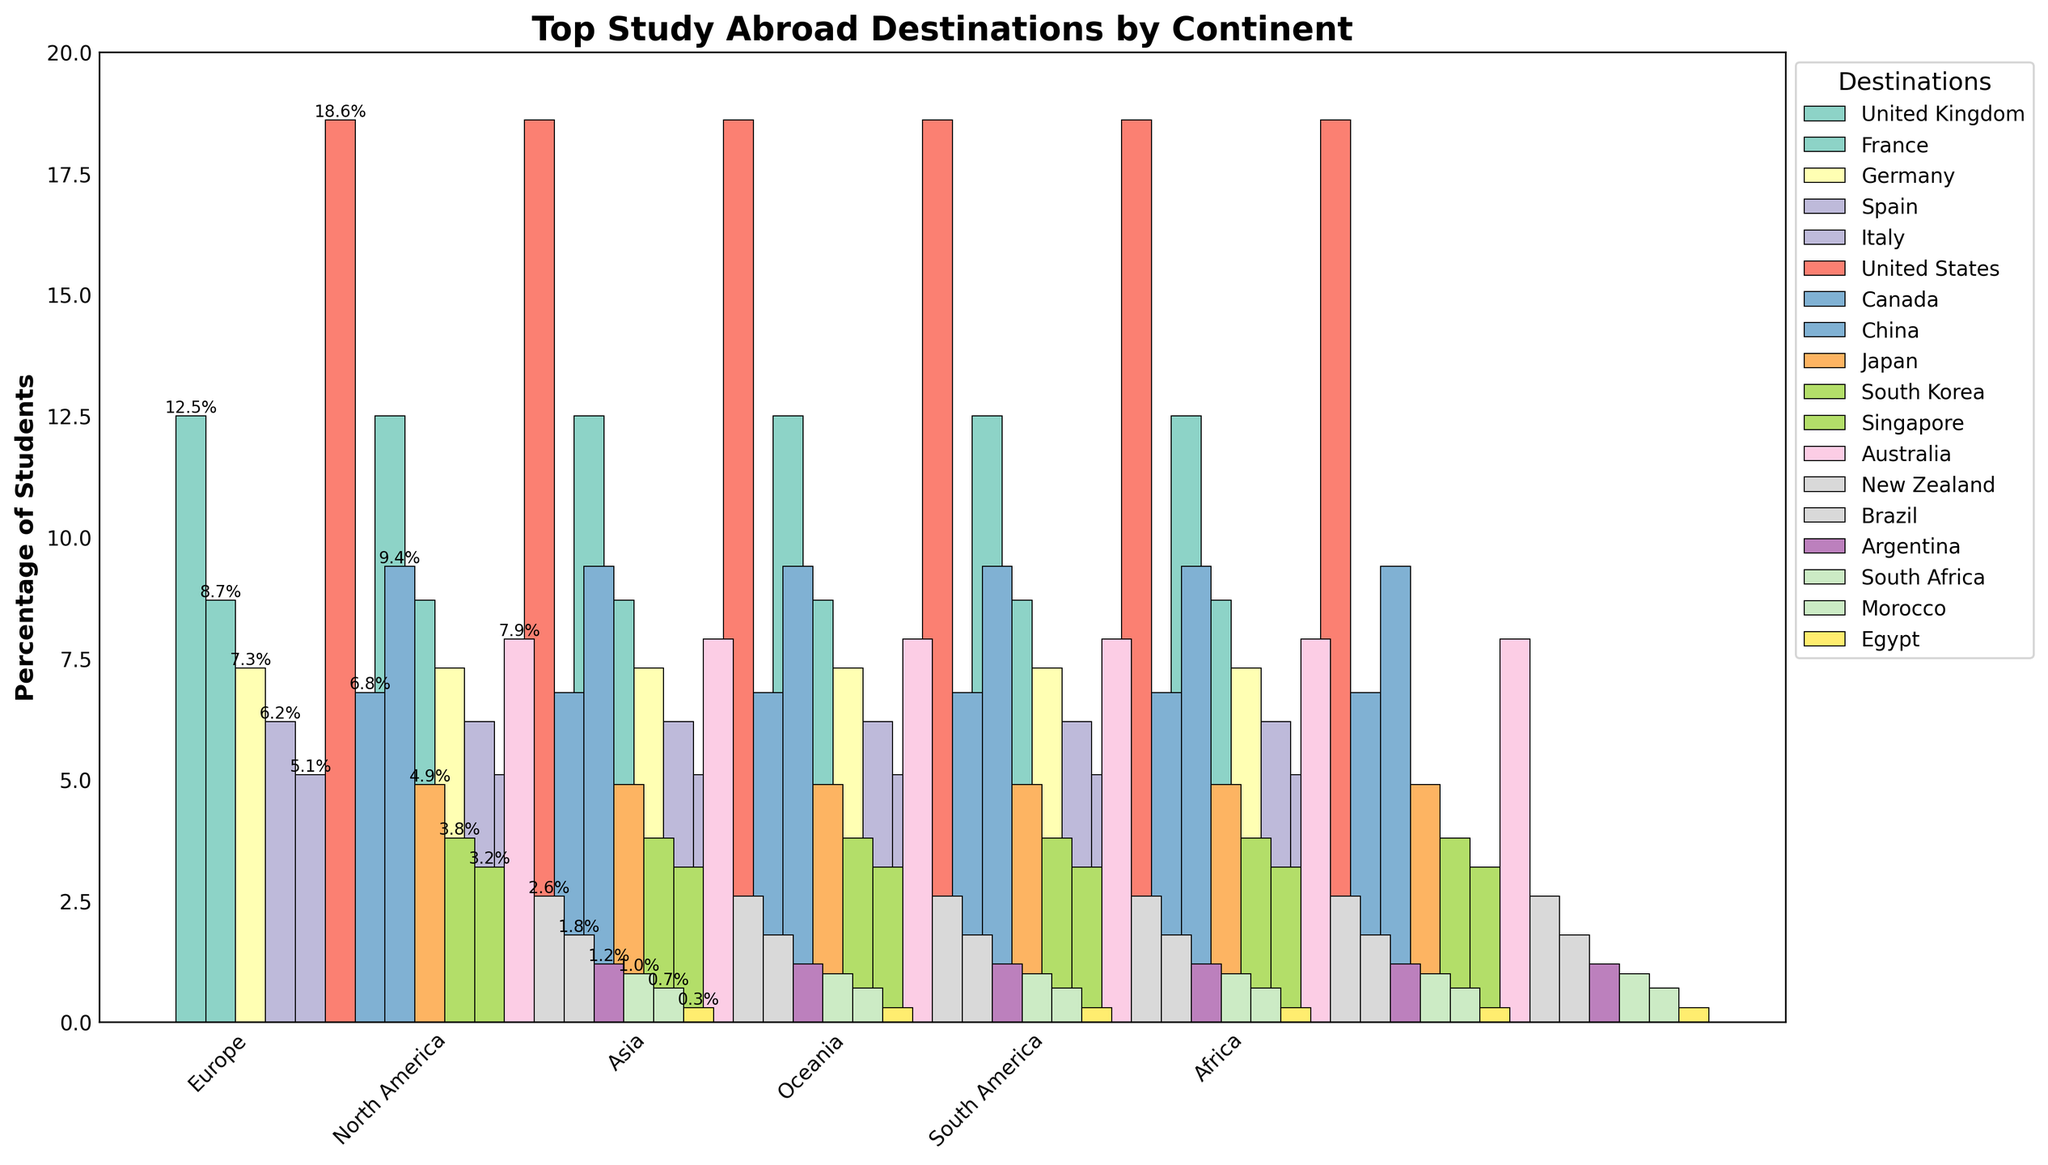Which continent has the highest percentage of students studying abroad? The continent with the highest percentage bar is North America, specifically the bar representing the United States at 18.6%.
Answer: North America Which country in Europe has the highest percentage of students studying abroad? In Europe, the tallest bar belongs to the United Kingdom, indicating that it has the highest percentage at 12.5%.
Answer: United Kingdom What is the total percentage of students studying abroad in Asia? Sum the percentages of China (9.4%), Japan (4.9%), South Korea (3.8%), and Singapore (3.2%). 9.4 + 4.9 + 3.8 + 3.2 = 21.3%.
Answer: 21.3% How does the percentage of students studying in Australia compare to those in Canada? Compare the height of the bars: Australia has 7.9% and Canada has 6.8%. Australia is higher.
Answer: Australia Which destination in Africa has the smallest percentage of students studying abroad? The shortest bar in Africa is for Egypt, which is 0.3%.
Answer: Egypt Are there more students studying abroad in Germany or Spain? The bar representing Germany is at 7.3%, while Spain is at 6.2%. Therefore, Germany has more students studying abroad.
Answer: Germany What is the difference in the percentage of students studying abroad between the United States and China? Subtract the percentage of China (9.4%) from the percentage of the United States (18.6%). 18.6 - 9.4 = 9.2%.
Answer: 9.2% Which destination in Europe is less popular, Spain or Italy? Compare the heights of the bars for Spain (6.2%) and Italy (5.1%). Italy is less popular.
Answer: Italy Which continent has the most destinations listed on the chart? Count the number of destinations per continent and compare: Europe (5), North America (2), Asia (4), Oceania (2), South America (2), Africa (3). Europe has the most.
Answer: Europe What is the average percentage of students studying abroad in Oceania? Average the percentages of Australia (7.9%) and New Zealand (2.6%). (7.9 + 2.6) / 2 = 5.25%.
Answer: 5.25% 